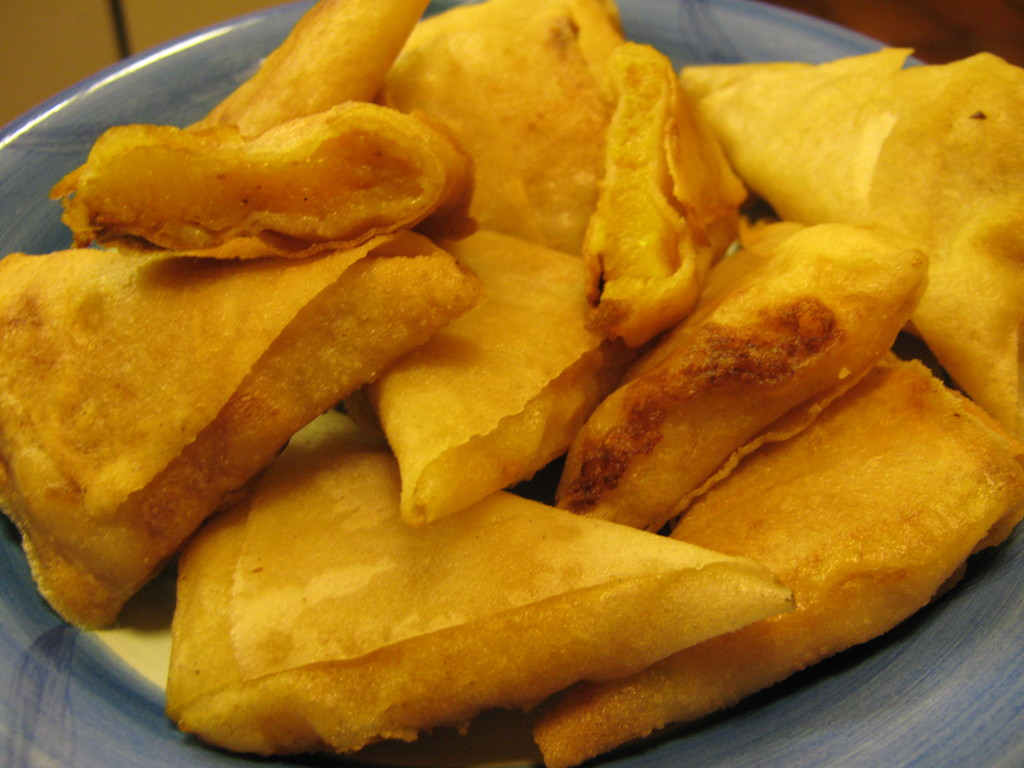Can I make this without fat or oil? It is possible to make these without oil or fat, but they may not be as crispy. You could try baking them or air-frying them instead of deep-frying. Baking them would require a longer cook time, but air-frying should be relatively quick. 